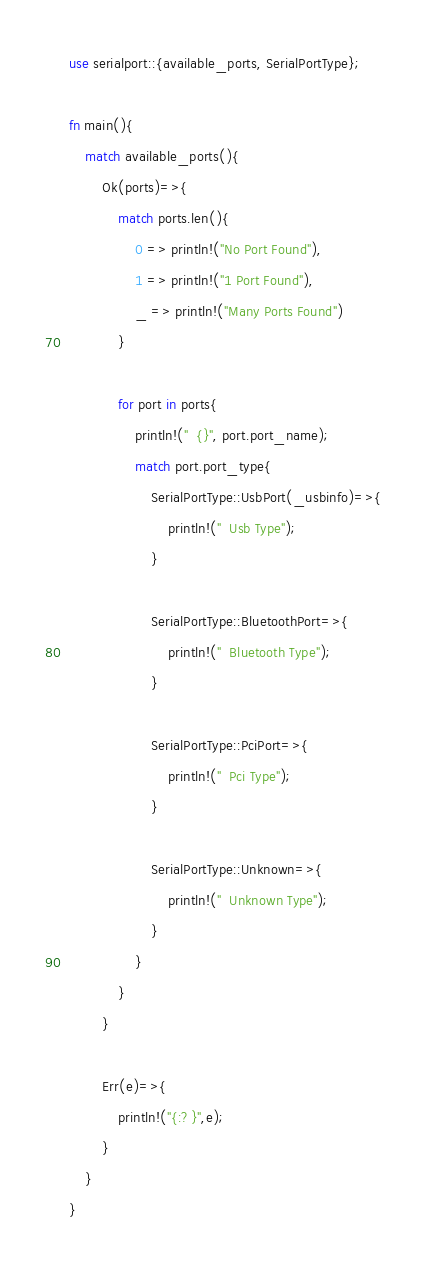<code> <loc_0><loc_0><loc_500><loc_500><_Rust_>use serialport::{available_ports, SerialPortType};

fn main(){
    match available_ports(){
        Ok(ports)=>{
            match ports.len(){
                0 => println!("No Port Found"),
                1 => println!("1 Port Found"),
                _ => println!("Many Ports Found")
            }

            for port in ports{
                println!("  {}", port.port_name);
                match port.port_type{
                    SerialPortType::UsbPort(_usbinfo)=>{
                        println!("  Usb Type");
                    }

                    SerialPortType::BluetoothPort=>{
                        println!("  Bluetooth Type");
                    }

                    SerialPortType::PciPort=>{
                        println!("  Pci Type");
                    }

                    SerialPortType::Unknown=>{
                        println!("  Unknown Type");
                    }
                }
            }
        }

        Err(e)=>{
            println!("{:?}",e);
        }
    }
}
</code> 